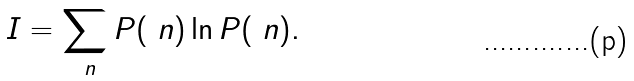Convert formula to latex. <formula><loc_0><loc_0><loc_500><loc_500>I = \sum _ { \ n } P ( \ n ) \ln { P ( \ n ) } .</formula> 